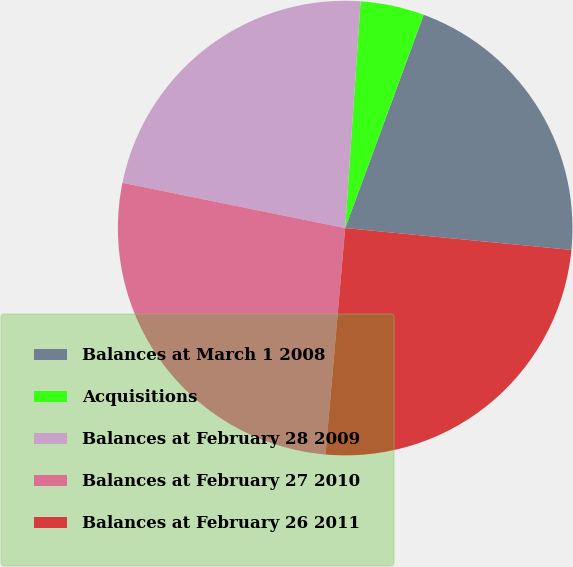Convert chart to OTSL. <chart><loc_0><loc_0><loc_500><loc_500><pie_chart><fcel>Balances at March 1 2008<fcel>Acquisitions<fcel>Balances at February 28 2009<fcel>Balances at February 27 2010<fcel>Balances at February 26 2011<nl><fcel>20.92%<fcel>4.53%<fcel>22.89%<fcel>26.81%<fcel>24.85%<nl></chart> 